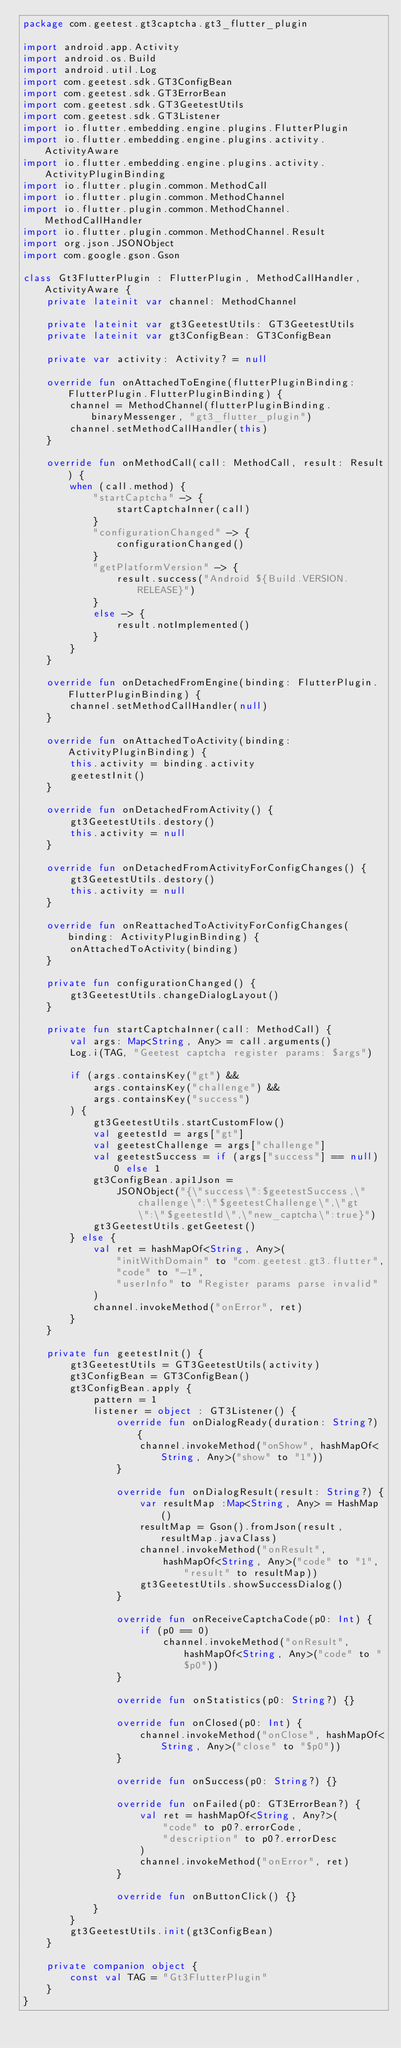<code> <loc_0><loc_0><loc_500><loc_500><_Kotlin_>package com.geetest.gt3captcha.gt3_flutter_plugin

import android.app.Activity
import android.os.Build
import android.util.Log
import com.geetest.sdk.GT3ConfigBean
import com.geetest.sdk.GT3ErrorBean
import com.geetest.sdk.GT3GeetestUtils
import com.geetest.sdk.GT3Listener
import io.flutter.embedding.engine.plugins.FlutterPlugin
import io.flutter.embedding.engine.plugins.activity.ActivityAware
import io.flutter.embedding.engine.plugins.activity.ActivityPluginBinding
import io.flutter.plugin.common.MethodCall
import io.flutter.plugin.common.MethodChannel
import io.flutter.plugin.common.MethodChannel.MethodCallHandler
import io.flutter.plugin.common.MethodChannel.Result
import org.json.JSONObject
import com.google.gson.Gson

class Gt3FlutterPlugin : FlutterPlugin, MethodCallHandler, ActivityAware {
    private lateinit var channel: MethodChannel

    private lateinit var gt3GeetestUtils: GT3GeetestUtils
    private lateinit var gt3ConfigBean: GT3ConfigBean

    private var activity: Activity? = null

    override fun onAttachedToEngine(flutterPluginBinding: FlutterPlugin.FlutterPluginBinding) {
        channel = MethodChannel(flutterPluginBinding.binaryMessenger, "gt3_flutter_plugin")
        channel.setMethodCallHandler(this)
    }

    override fun onMethodCall(call: MethodCall, result: Result) {
        when (call.method) {
            "startCaptcha" -> {
                startCaptchaInner(call)
            }
            "configurationChanged" -> {
                configurationChanged()
            }
            "getPlatformVersion" -> {
                result.success("Android ${Build.VERSION.RELEASE}")
            }
            else -> {
                result.notImplemented()
            }
        }
    }

    override fun onDetachedFromEngine(binding: FlutterPlugin.FlutterPluginBinding) {
        channel.setMethodCallHandler(null)
    }

    override fun onAttachedToActivity(binding: ActivityPluginBinding) {
        this.activity = binding.activity
        geetestInit()
    }

    override fun onDetachedFromActivity() {
        gt3GeetestUtils.destory()
        this.activity = null
    }

    override fun onDetachedFromActivityForConfigChanges() {
        gt3GeetestUtils.destory()
        this.activity = null
    }

    override fun onReattachedToActivityForConfigChanges(binding: ActivityPluginBinding) {
        onAttachedToActivity(binding)
    }

    private fun configurationChanged() {
        gt3GeetestUtils.changeDialogLayout()
    }

    private fun startCaptchaInner(call: MethodCall) {
        val args: Map<String, Any> = call.arguments()
        Log.i(TAG, "Geetest captcha register params: $args")

        if (args.containsKey("gt") &&
            args.containsKey("challenge") &&
            args.containsKey("success")
        ) {
            gt3GeetestUtils.startCustomFlow()
            val geetestId = args["gt"]
            val geetestChallenge = args["challenge"]
            val geetestSuccess = if (args["success"] == null) 0 else 1
            gt3ConfigBean.api1Json =
                JSONObject("{\"success\":$geetestSuccess,\"challenge\":\"$geetestChallenge\",\"gt\":\"$geetestId\",\"new_captcha\":true}")
            gt3GeetestUtils.getGeetest()
        } else {
            val ret = hashMapOf<String, Any>(
                "initWithDomain" to "com.geetest.gt3.flutter",
                "code" to "-1",
                "userInfo" to "Register params parse invalid"
            )
            channel.invokeMethod("onError", ret)
        }
    }

    private fun geetestInit() {
        gt3GeetestUtils = GT3GeetestUtils(activity)
        gt3ConfigBean = GT3ConfigBean()
        gt3ConfigBean.apply {
            pattern = 1
            listener = object : GT3Listener() {
                override fun onDialogReady(duration: String?) {
                    channel.invokeMethod("onShow", hashMapOf<String, Any>("show" to "1"))
                }

                override fun onDialogResult(result: String?) {
                    var resultMap :Map<String, Any> = HashMap()
                    resultMap = Gson().fromJson(result, resultMap.javaClass)
                    channel.invokeMethod("onResult",
                        hashMapOf<String, Any>("code" to "1", "result" to resultMap))
                    gt3GeetestUtils.showSuccessDialog()
                }

                override fun onReceiveCaptchaCode(p0: Int) {
                    if (p0 == 0)
                        channel.invokeMethod("onResult", hashMapOf<String, Any>("code" to "$p0"))
                }

                override fun onStatistics(p0: String?) {}

                override fun onClosed(p0: Int) {
                    channel.invokeMethod("onClose", hashMapOf<String, Any>("close" to "$p0"))
                }

                override fun onSuccess(p0: String?) {}

                override fun onFailed(p0: GT3ErrorBean?) {
                    val ret = hashMapOf<String, Any?>(
                        "code" to p0?.errorCode,
                        "description" to p0?.errorDesc
                    )
                    channel.invokeMethod("onError", ret)
                }

                override fun onButtonClick() {}
            }
        }
        gt3GeetestUtils.init(gt3ConfigBean)
    }

    private companion object {
        const val TAG = "Gt3FlutterPlugin"
    }
}
</code> 